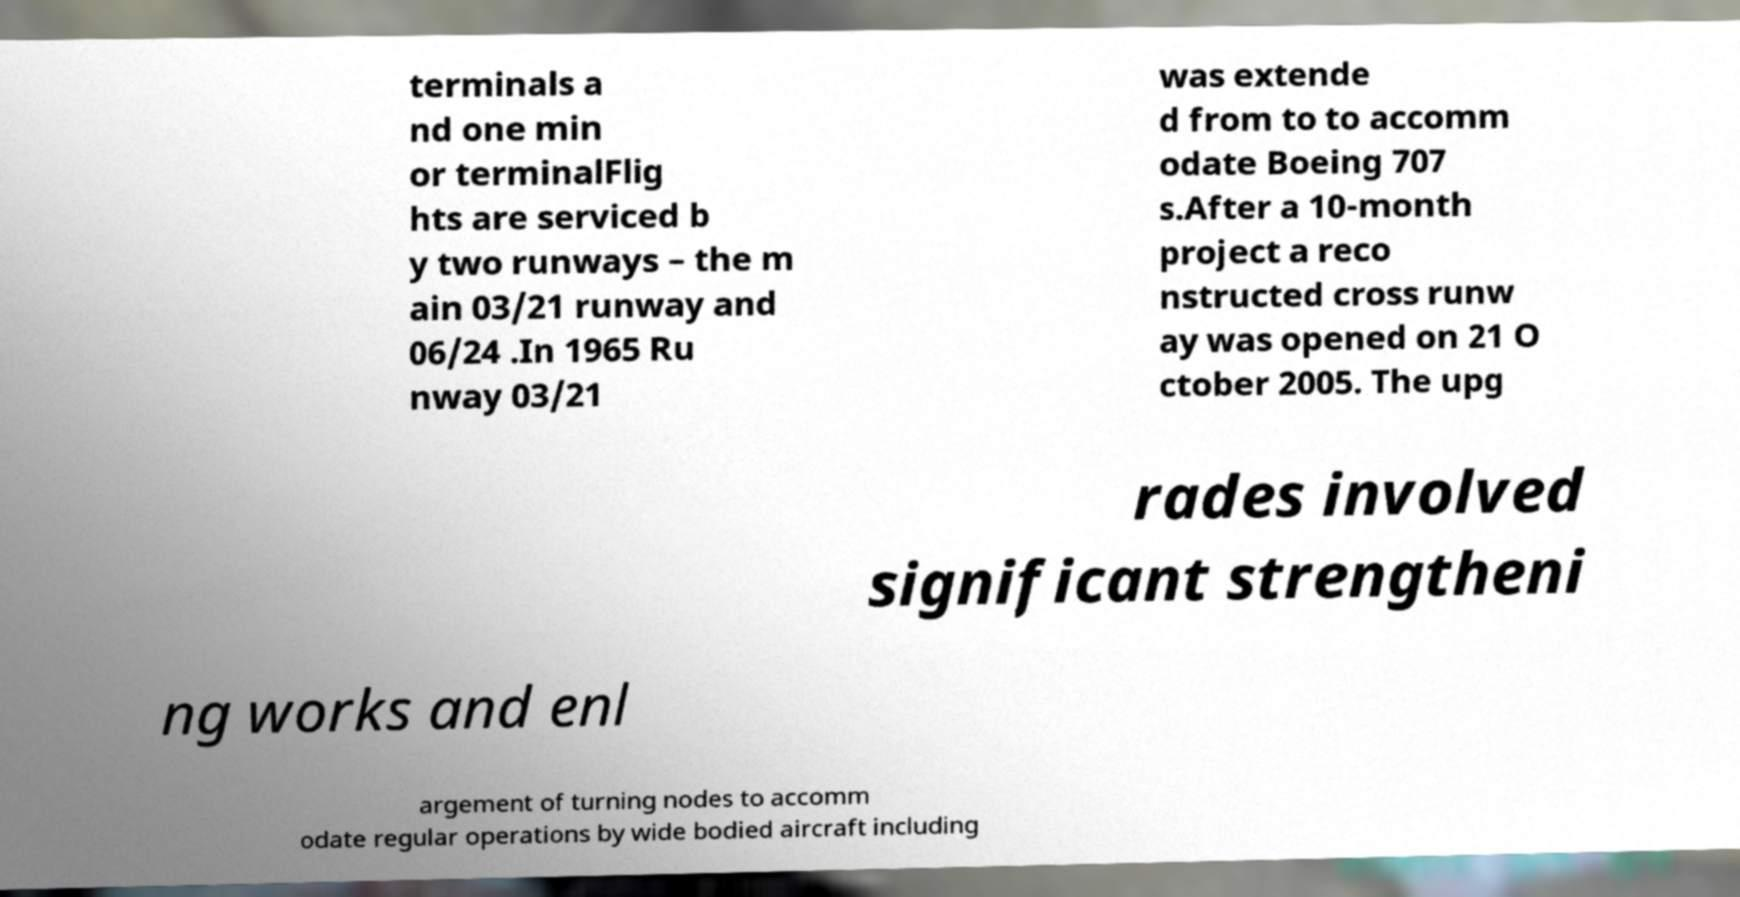Could you assist in decoding the text presented in this image and type it out clearly? terminals a nd one min or terminalFlig hts are serviced b y two runways – the m ain 03/21 runway and 06/24 .In 1965 Ru nway 03/21 was extende d from to to accomm odate Boeing 707 s.After a 10-month project a reco nstructed cross runw ay was opened on 21 O ctober 2005. The upg rades involved significant strengtheni ng works and enl argement of turning nodes to accomm odate regular operations by wide bodied aircraft including 